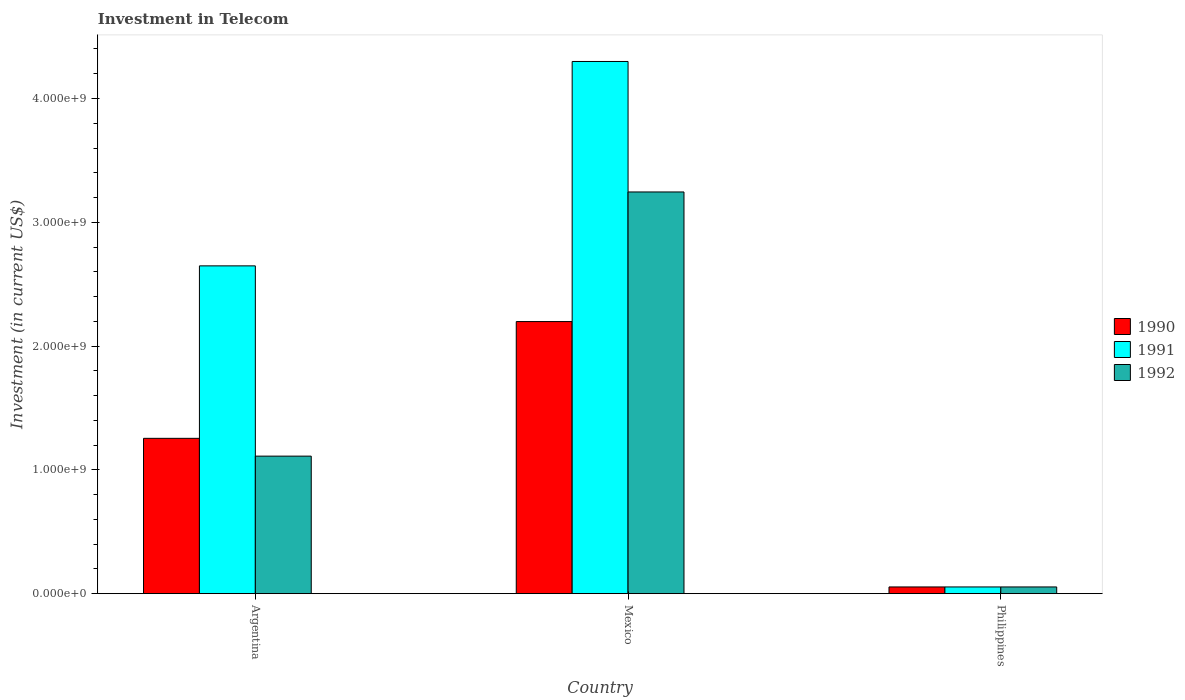How many different coloured bars are there?
Offer a terse response. 3. How many groups of bars are there?
Give a very brief answer. 3. Are the number of bars per tick equal to the number of legend labels?
Your answer should be very brief. Yes. Are the number of bars on each tick of the X-axis equal?
Your answer should be compact. Yes. In how many cases, is the number of bars for a given country not equal to the number of legend labels?
Keep it short and to the point. 0. What is the amount invested in telecom in 1990 in Argentina?
Keep it short and to the point. 1.25e+09. Across all countries, what is the maximum amount invested in telecom in 1992?
Provide a succinct answer. 3.24e+09. Across all countries, what is the minimum amount invested in telecom in 1990?
Your answer should be compact. 5.42e+07. In which country was the amount invested in telecom in 1991 maximum?
Your answer should be compact. Mexico. In which country was the amount invested in telecom in 1990 minimum?
Your response must be concise. Philippines. What is the total amount invested in telecom in 1991 in the graph?
Make the answer very short. 7.00e+09. What is the difference between the amount invested in telecom in 1992 in Mexico and that in Philippines?
Give a very brief answer. 3.19e+09. What is the difference between the amount invested in telecom in 1991 in Philippines and the amount invested in telecom in 1990 in Argentina?
Your answer should be compact. -1.20e+09. What is the average amount invested in telecom in 1991 per country?
Your response must be concise. 2.33e+09. What is the difference between the amount invested in telecom of/in 1990 and amount invested in telecom of/in 1991 in Philippines?
Provide a short and direct response. 0. What is the ratio of the amount invested in telecom in 1992 in Mexico to that in Philippines?
Offer a terse response. 59.87. Is the difference between the amount invested in telecom in 1990 in Mexico and Philippines greater than the difference between the amount invested in telecom in 1991 in Mexico and Philippines?
Your answer should be very brief. No. What is the difference between the highest and the second highest amount invested in telecom in 1992?
Provide a succinct answer. 3.19e+09. What is the difference between the highest and the lowest amount invested in telecom in 1992?
Offer a terse response. 3.19e+09. In how many countries, is the amount invested in telecom in 1991 greater than the average amount invested in telecom in 1991 taken over all countries?
Provide a short and direct response. 2. Is the sum of the amount invested in telecom in 1990 in Mexico and Philippines greater than the maximum amount invested in telecom in 1992 across all countries?
Keep it short and to the point. No. What does the 3rd bar from the left in Mexico represents?
Offer a very short reply. 1992. How many bars are there?
Provide a succinct answer. 9. Are all the bars in the graph horizontal?
Make the answer very short. No. How many countries are there in the graph?
Provide a succinct answer. 3. Does the graph contain any zero values?
Keep it short and to the point. No. What is the title of the graph?
Give a very brief answer. Investment in Telecom. What is the label or title of the X-axis?
Keep it short and to the point. Country. What is the label or title of the Y-axis?
Provide a succinct answer. Investment (in current US$). What is the Investment (in current US$) in 1990 in Argentina?
Your response must be concise. 1.25e+09. What is the Investment (in current US$) of 1991 in Argentina?
Your answer should be compact. 2.65e+09. What is the Investment (in current US$) in 1992 in Argentina?
Ensure brevity in your answer.  1.11e+09. What is the Investment (in current US$) in 1990 in Mexico?
Make the answer very short. 2.20e+09. What is the Investment (in current US$) of 1991 in Mexico?
Make the answer very short. 4.30e+09. What is the Investment (in current US$) in 1992 in Mexico?
Make the answer very short. 3.24e+09. What is the Investment (in current US$) of 1990 in Philippines?
Provide a short and direct response. 5.42e+07. What is the Investment (in current US$) in 1991 in Philippines?
Provide a short and direct response. 5.42e+07. What is the Investment (in current US$) of 1992 in Philippines?
Provide a short and direct response. 5.42e+07. Across all countries, what is the maximum Investment (in current US$) of 1990?
Offer a very short reply. 2.20e+09. Across all countries, what is the maximum Investment (in current US$) of 1991?
Your answer should be very brief. 4.30e+09. Across all countries, what is the maximum Investment (in current US$) of 1992?
Provide a short and direct response. 3.24e+09. Across all countries, what is the minimum Investment (in current US$) in 1990?
Give a very brief answer. 5.42e+07. Across all countries, what is the minimum Investment (in current US$) in 1991?
Ensure brevity in your answer.  5.42e+07. Across all countries, what is the minimum Investment (in current US$) in 1992?
Provide a succinct answer. 5.42e+07. What is the total Investment (in current US$) in 1990 in the graph?
Provide a short and direct response. 3.51e+09. What is the total Investment (in current US$) of 1991 in the graph?
Your response must be concise. 7.00e+09. What is the total Investment (in current US$) of 1992 in the graph?
Provide a short and direct response. 4.41e+09. What is the difference between the Investment (in current US$) in 1990 in Argentina and that in Mexico?
Ensure brevity in your answer.  -9.43e+08. What is the difference between the Investment (in current US$) in 1991 in Argentina and that in Mexico?
Your response must be concise. -1.65e+09. What is the difference between the Investment (in current US$) of 1992 in Argentina and that in Mexico?
Provide a short and direct response. -2.13e+09. What is the difference between the Investment (in current US$) in 1990 in Argentina and that in Philippines?
Provide a short and direct response. 1.20e+09. What is the difference between the Investment (in current US$) of 1991 in Argentina and that in Philippines?
Make the answer very short. 2.59e+09. What is the difference between the Investment (in current US$) of 1992 in Argentina and that in Philippines?
Offer a very short reply. 1.06e+09. What is the difference between the Investment (in current US$) of 1990 in Mexico and that in Philippines?
Your response must be concise. 2.14e+09. What is the difference between the Investment (in current US$) of 1991 in Mexico and that in Philippines?
Give a very brief answer. 4.24e+09. What is the difference between the Investment (in current US$) of 1992 in Mexico and that in Philippines?
Your response must be concise. 3.19e+09. What is the difference between the Investment (in current US$) in 1990 in Argentina and the Investment (in current US$) in 1991 in Mexico?
Offer a very short reply. -3.04e+09. What is the difference between the Investment (in current US$) in 1990 in Argentina and the Investment (in current US$) in 1992 in Mexico?
Ensure brevity in your answer.  -1.99e+09. What is the difference between the Investment (in current US$) of 1991 in Argentina and the Investment (in current US$) of 1992 in Mexico?
Your response must be concise. -5.97e+08. What is the difference between the Investment (in current US$) in 1990 in Argentina and the Investment (in current US$) in 1991 in Philippines?
Give a very brief answer. 1.20e+09. What is the difference between the Investment (in current US$) in 1990 in Argentina and the Investment (in current US$) in 1992 in Philippines?
Your response must be concise. 1.20e+09. What is the difference between the Investment (in current US$) in 1991 in Argentina and the Investment (in current US$) in 1992 in Philippines?
Ensure brevity in your answer.  2.59e+09. What is the difference between the Investment (in current US$) in 1990 in Mexico and the Investment (in current US$) in 1991 in Philippines?
Make the answer very short. 2.14e+09. What is the difference between the Investment (in current US$) in 1990 in Mexico and the Investment (in current US$) in 1992 in Philippines?
Keep it short and to the point. 2.14e+09. What is the difference between the Investment (in current US$) in 1991 in Mexico and the Investment (in current US$) in 1992 in Philippines?
Give a very brief answer. 4.24e+09. What is the average Investment (in current US$) in 1990 per country?
Ensure brevity in your answer.  1.17e+09. What is the average Investment (in current US$) of 1991 per country?
Make the answer very short. 2.33e+09. What is the average Investment (in current US$) of 1992 per country?
Your answer should be compact. 1.47e+09. What is the difference between the Investment (in current US$) in 1990 and Investment (in current US$) in 1991 in Argentina?
Your answer should be very brief. -1.39e+09. What is the difference between the Investment (in current US$) of 1990 and Investment (in current US$) of 1992 in Argentina?
Ensure brevity in your answer.  1.44e+08. What is the difference between the Investment (in current US$) in 1991 and Investment (in current US$) in 1992 in Argentina?
Your answer should be compact. 1.54e+09. What is the difference between the Investment (in current US$) of 1990 and Investment (in current US$) of 1991 in Mexico?
Give a very brief answer. -2.10e+09. What is the difference between the Investment (in current US$) of 1990 and Investment (in current US$) of 1992 in Mexico?
Your answer should be compact. -1.05e+09. What is the difference between the Investment (in current US$) of 1991 and Investment (in current US$) of 1992 in Mexico?
Make the answer very short. 1.05e+09. What is the difference between the Investment (in current US$) in 1990 and Investment (in current US$) in 1991 in Philippines?
Offer a terse response. 0. What is the difference between the Investment (in current US$) of 1990 and Investment (in current US$) of 1992 in Philippines?
Your response must be concise. 0. What is the difference between the Investment (in current US$) in 1991 and Investment (in current US$) in 1992 in Philippines?
Offer a terse response. 0. What is the ratio of the Investment (in current US$) of 1990 in Argentina to that in Mexico?
Ensure brevity in your answer.  0.57. What is the ratio of the Investment (in current US$) of 1991 in Argentina to that in Mexico?
Offer a very short reply. 0.62. What is the ratio of the Investment (in current US$) of 1992 in Argentina to that in Mexico?
Make the answer very short. 0.34. What is the ratio of the Investment (in current US$) in 1990 in Argentina to that in Philippines?
Provide a succinct answer. 23.15. What is the ratio of the Investment (in current US$) in 1991 in Argentina to that in Philippines?
Offer a very short reply. 48.86. What is the ratio of the Investment (in current US$) of 1992 in Argentina to that in Philippines?
Provide a short and direct response. 20.5. What is the ratio of the Investment (in current US$) of 1990 in Mexico to that in Philippines?
Your answer should be very brief. 40.55. What is the ratio of the Investment (in current US$) of 1991 in Mexico to that in Philippines?
Your answer should be compact. 79.32. What is the ratio of the Investment (in current US$) in 1992 in Mexico to that in Philippines?
Ensure brevity in your answer.  59.87. What is the difference between the highest and the second highest Investment (in current US$) in 1990?
Keep it short and to the point. 9.43e+08. What is the difference between the highest and the second highest Investment (in current US$) of 1991?
Keep it short and to the point. 1.65e+09. What is the difference between the highest and the second highest Investment (in current US$) of 1992?
Keep it short and to the point. 2.13e+09. What is the difference between the highest and the lowest Investment (in current US$) in 1990?
Offer a terse response. 2.14e+09. What is the difference between the highest and the lowest Investment (in current US$) of 1991?
Keep it short and to the point. 4.24e+09. What is the difference between the highest and the lowest Investment (in current US$) of 1992?
Your answer should be very brief. 3.19e+09. 